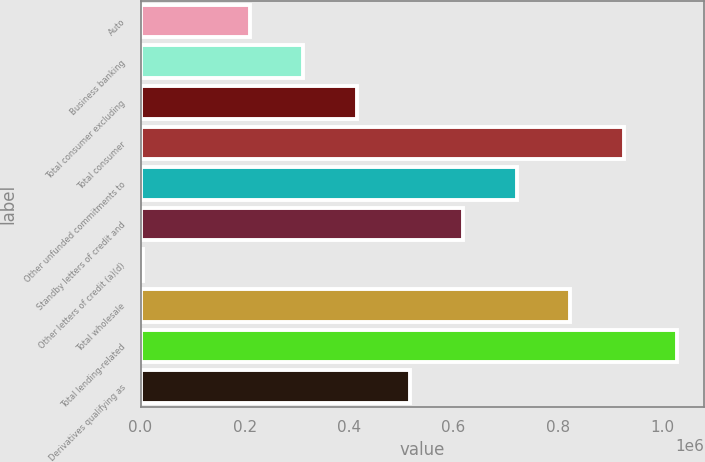Convert chart to OTSL. <chart><loc_0><loc_0><loc_500><loc_500><bar_chart><fcel>Auto<fcel>Business banking<fcel>Total consumer excluding<fcel>Total consumer<fcel>Other unfunded commitments to<fcel>Standby letters of credit and<fcel>Other letters of credit (a)(d)<fcel>Total wholesale<fcel>Total lending-related<fcel>Derivatives qualifying as<nl><fcel>210056<fcel>312298<fcel>414539<fcel>925746<fcel>721264<fcel>619022<fcel>5573<fcel>823505<fcel>1.02799e+06<fcel>516780<nl></chart> 